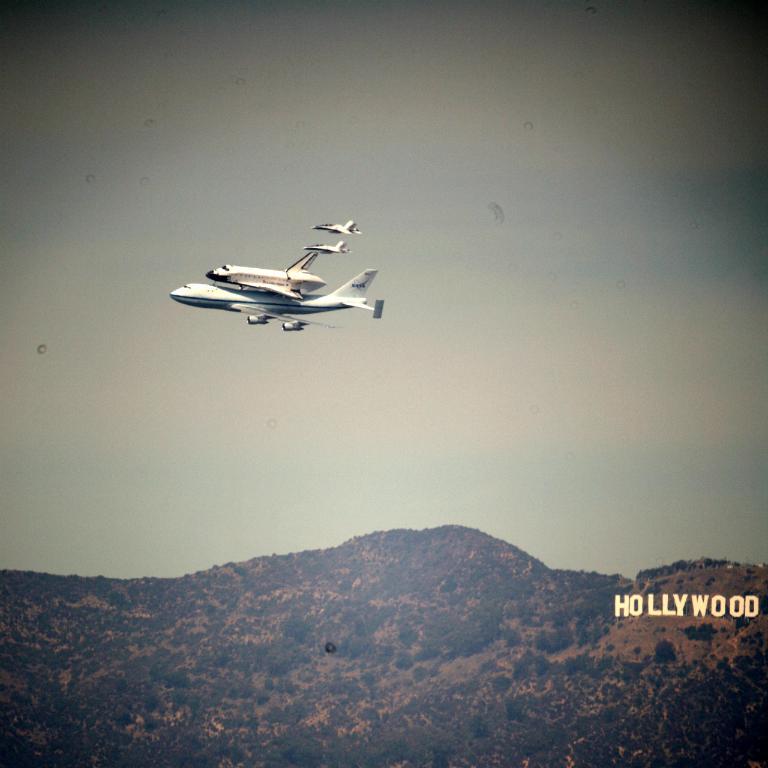Where is the airplane flying?
Your answer should be very brief. Hollywood. What large city is the sign saying on the hillside?
Make the answer very short. Hollywood. 